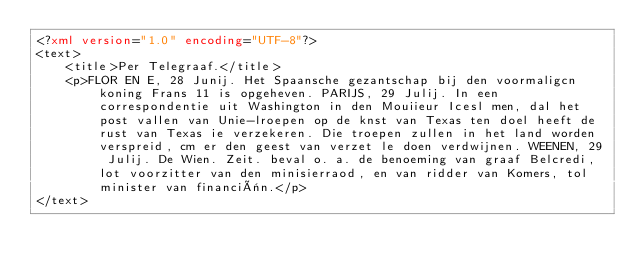Convert code to text. <code><loc_0><loc_0><loc_500><loc_500><_XML_><?xml version="1.0" encoding="UTF-8"?>
<text>
	<title>Per Telegraaf.</title>
	<p>FLOR EN E, 28 Junij. Het Spaansche gezantschap bij den voormaligcn koning Frans 11 is opgeheven. PARIJS, 29 Julij. In een correspondentie uit Washington in den Mouiieur Icesl men, dal het post vallen van Unie-lroepen op de knst van Texas ten doel heeft de rust van Texas ie verzekeren. Die troepen zullen in het land worden verspreid, cm er den geest van verzet le doen verdwijnen. WEENEN, 29 Julij. De Wien. Zeit. beval o. a. de benoeming van graaf Belcredi, lot voorzitter van den minisierraod, en van ridder van Komers, tol minister van financiën.</p>
</text>
</code> 